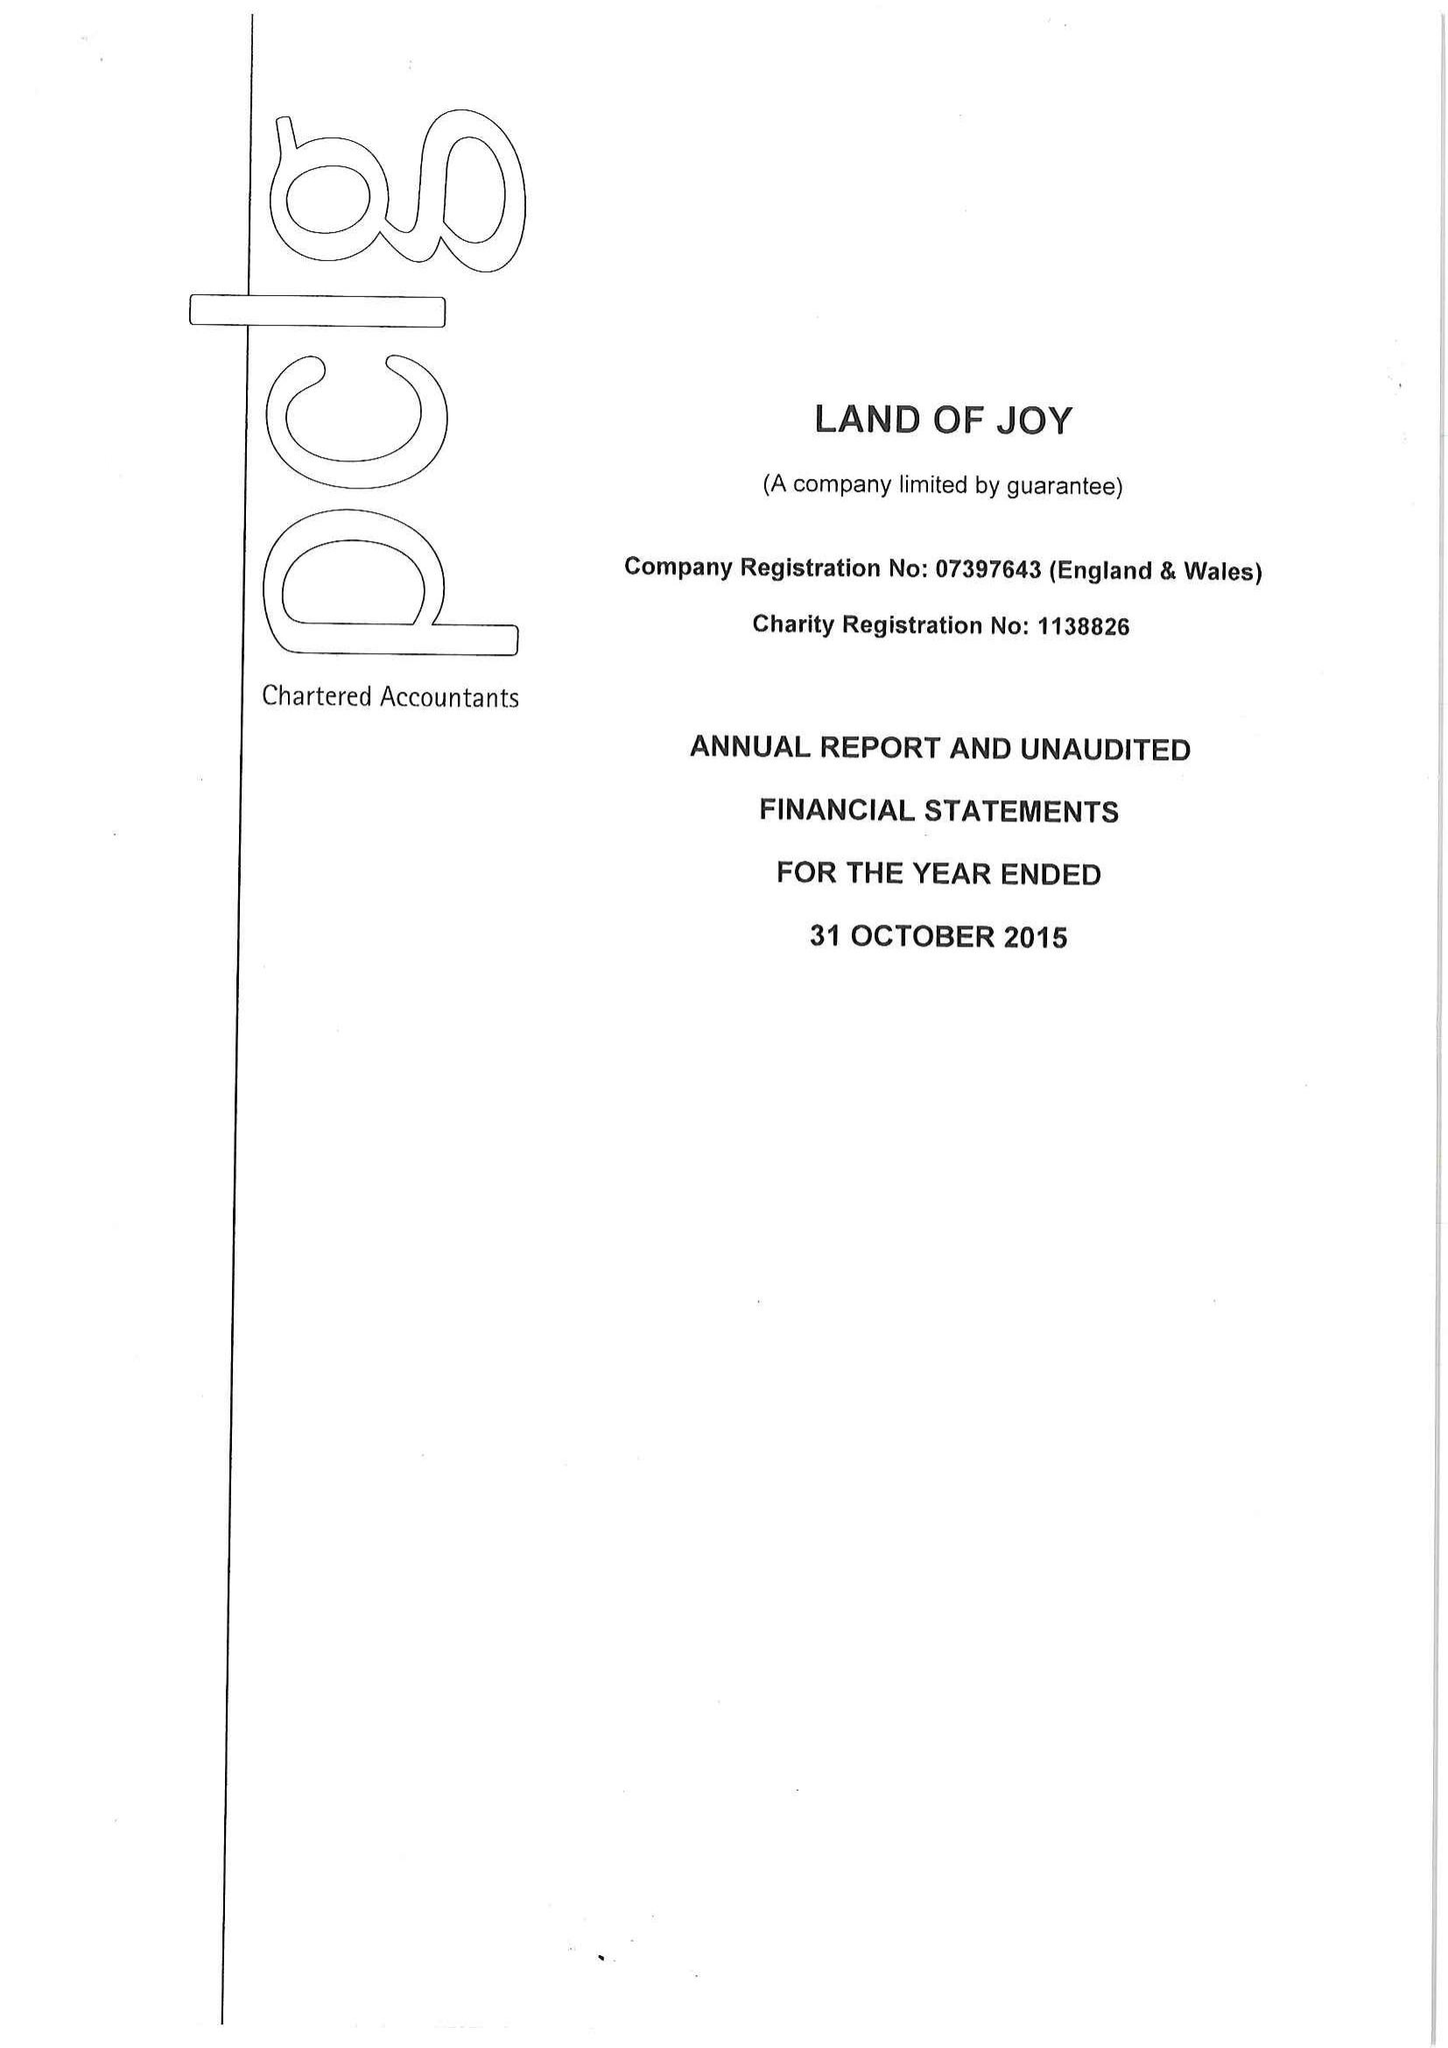What is the value for the charity_number?
Answer the question using a single word or phrase. 1138826 